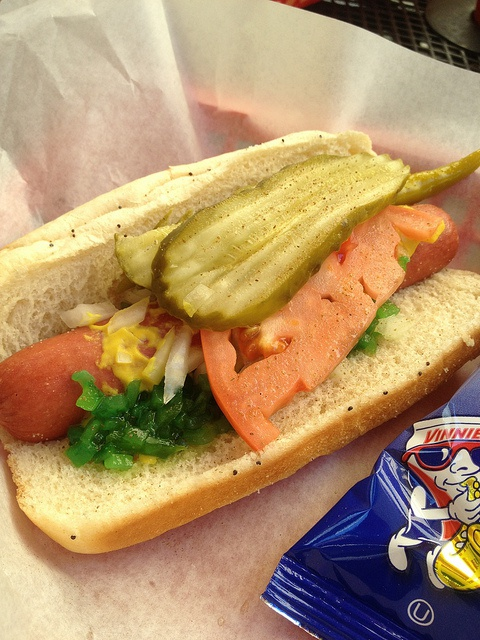Describe the objects in this image and their specific colors. I can see a hot dog in gray, tan, khaki, and brown tones in this image. 